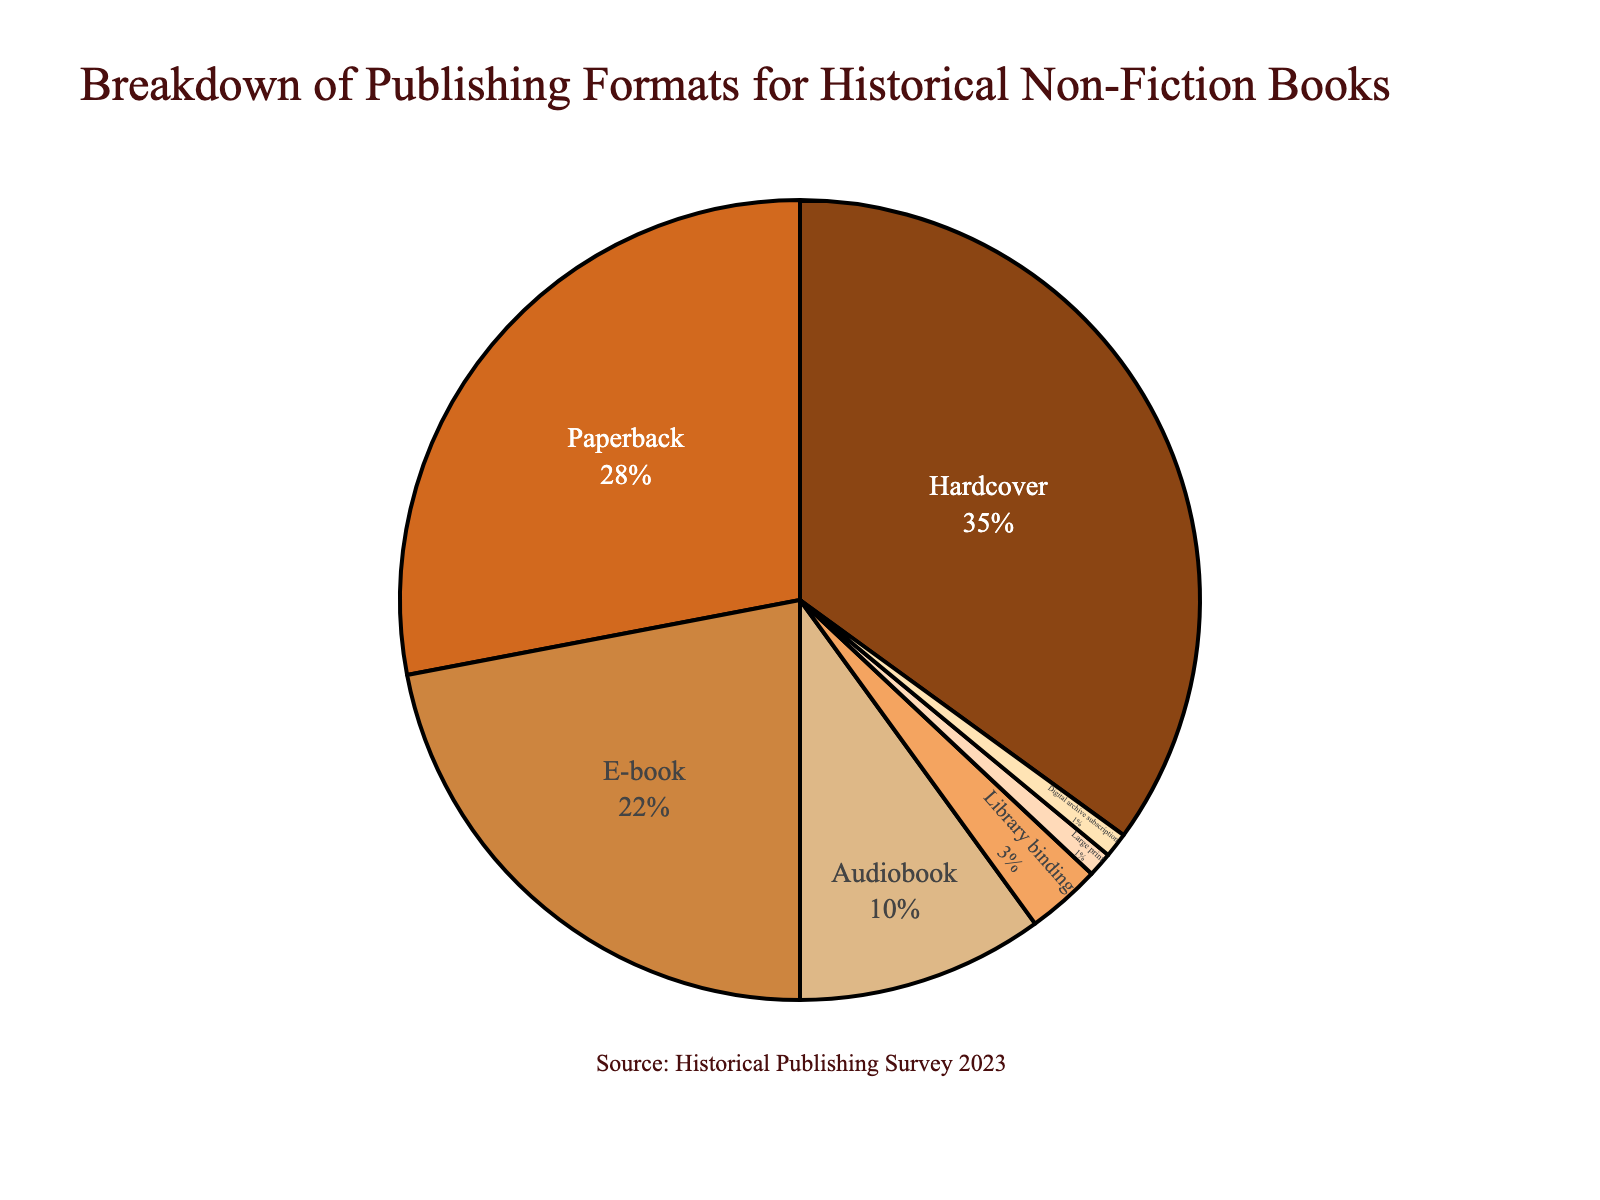Which publishing format holds the largest share for historical non-fiction books? The pie chart shows that Hardcover has the largest segment among all publishing formats.
Answer: Hardcover What is the combined percentage of Hardcover and Paperback formats? The chart indicates that Hardcover has 35% and Paperback has 28%, so combined, they account for 35 + 28 = 63%.
Answer: 63% Which publishing format has the smallest share? The pie chart reveals that Large print and Digital archive subscription each hold the smallest share at 1%.
Answer: Large print, Digital archive subscription Is the percentage of Audiobooks greater than that of Library binding? The pie chart shows that Audiobooks account for 10% while Library binding accounts for 3%. Since 10% is greater than 3%, Audiobooks have a larger share.
Answer: Yes What is the difference in percentage between E-books and Audiobooks? According to the pie chart, E-books have a share of 22% and Audiobooks have 10%. The difference is calculated as 22 - 10 = 12%.
Answer: 12% Are Paperback and E-book formats used by more than half of the market collectively? The pie chart shows that Paperback accounts for 28% and E-book for 22%. Combined, they account for 28 + 22 = 50%. Since 50% is exactly half, they are not used by more than half.
Answer: No Which color represents the E-book format in the pie chart? The pie chart uses various colors and one of the segments is colored brown.
Answer: Brown How many formats make up less than 10% of the total distribution individually? Reviewing the pie chart, formats less than 10% are Audiobook (10%), Library binding (3%), Large print (1%), and Digital archive subscription (1%). There are 4 such formats.
Answer: 4 What is the median percentage among all formats shown in the chart? The percentages are: 35, 28, 22, 10, 3, 1, 1. Ordered: 1, 1, 3, 10, 22, 28, 35. The middle value in this ordered list is 10.
Answer: 10% If the percentages of Paperback and Library binding were combined, would they exceed the percentage of Hardcover? Paperback is 28% and Library binding is 3%, combined they are 28 + 3 = 31%. Since Hardcover is 35%, the combined percentage is less.
Answer: No 